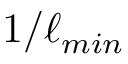Convert formula to latex. <formula><loc_0><loc_0><loc_500><loc_500>1 / \ell _ { \min }</formula> 